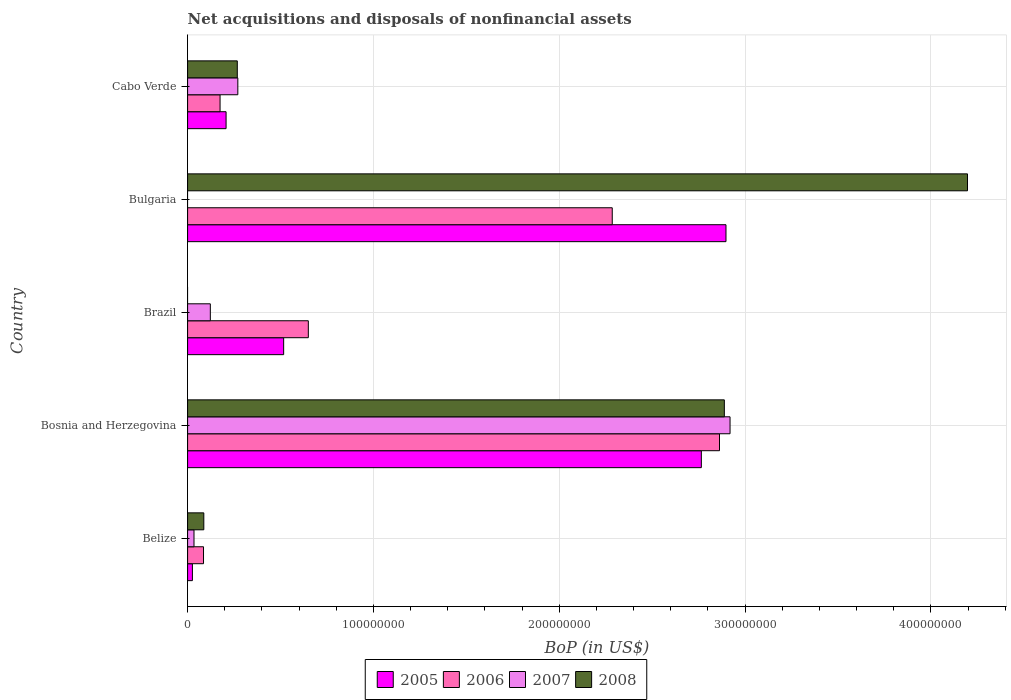How many groups of bars are there?
Offer a very short reply. 5. What is the label of the 4th group of bars from the top?
Offer a very short reply. Bosnia and Herzegovina. In how many cases, is the number of bars for a given country not equal to the number of legend labels?
Make the answer very short. 2. What is the Balance of Payments in 2007 in Bosnia and Herzegovina?
Provide a short and direct response. 2.92e+08. Across all countries, what is the maximum Balance of Payments in 2008?
Offer a very short reply. 4.20e+08. In which country was the Balance of Payments in 2005 maximum?
Ensure brevity in your answer.  Bulgaria. What is the total Balance of Payments in 2007 in the graph?
Keep it short and to the point. 3.35e+08. What is the difference between the Balance of Payments in 2007 in Bosnia and Herzegovina and that in Brazil?
Make the answer very short. 2.80e+08. What is the difference between the Balance of Payments in 2008 in Brazil and the Balance of Payments in 2006 in Bosnia and Herzegovina?
Ensure brevity in your answer.  -2.86e+08. What is the average Balance of Payments in 2005 per country?
Offer a terse response. 1.28e+08. What is the difference between the Balance of Payments in 2005 and Balance of Payments in 2007 in Belize?
Provide a succinct answer. -8.56e+05. What is the ratio of the Balance of Payments in 2008 in Bosnia and Herzegovina to that in Bulgaria?
Your response must be concise. 0.69. Is the Balance of Payments in 2006 in Bosnia and Herzegovina less than that in Brazil?
Give a very brief answer. No. What is the difference between the highest and the second highest Balance of Payments in 2006?
Offer a terse response. 5.77e+07. What is the difference between the highest and the lowest Balance of Payments in 2007?
Offer a very short reply. 2.92e+08. In how many countries, is the Balance of Payments in 2006 greater than the average Balance of Payments in 2006 taken over all countries?
Your answer should be compact. 2. Is the sum of the Balance of Payments in 2008 in Bosnia and Herzegovina and Cabo Verde greater than the maximum Balance of Payments in 2006 across all countries?
Provide a succinct answer. Yes. Is it the case that in every country, the sum of the Balance of Payments in 2006 and Balance of Payments in 2008 is greater than the sum of Balance of Payments in 2005 and Balance of Payments in 2007?
Your answer should be compact. Yes. Is it the case that in every country, the sum of the Balance of Payments in 2007 and Balance of Payments in 2006 is greater than the Balance of Payments in 2005?
Keep it short and to the point. No. How many bars are there?
Your response must be concise. 18. Are the values on the major ticks of X-axis written in scientific E-notation?
Offer a very short reply. No. Does the graph contain any zero values?
Give a very brief answer. Yes. Does the graph contain grids?
Make the answer very short. Yes. Where does the legend appear in the graph?
Offer a very short reply. Bottom center. How are the legend labels stacked?
Keep it short and to the point. Horizontal. What is the title of the graph?
Your answer should be compact. Net acquisitions and disposals of nonfinancial assets. Does "1970" appear as one of the legend labels in the graph?
Your answer should be very brief. No. What is the label or title of the X-axis?
Your answer should be compact. BoP (in US$). What is the BoP (in US$) in 2005 in Belize?
Offer a very short reply. 2.59e+06. What is the BoP (in US$) in 2006 in Belize?
Provide a succinct answer. 8.57e+06. What is the BoP (in US$) of 2007 in Belize?
Offer a terse response. 3.45e+06. What is the BoP (in US$) of 2008 in Belize?
Ensure brevity in your answer.  8.73e+06. What is the BoP (in US$) of 2005 in Bosnia and Herzegovina?
Your response must be concise. 2.76e+08. What is the BoP (in US$) in 2006 in Bosnia and Herzegovina?
Keep it short and to the point. 2.86e+08. What is the BoP (in US$) in 2007 in Bosnia and Herzegovina?
Your answer should be compact. 2.92e+08. What is the BoP (in US$) of 2008 in Bosnia and Herzegovina?
Give a very brief answer. 2.89e+08. What is the BoP (in US$) in 2005 in Brazil?
Provide a short and direct response. 5.17e+07. What is the BoP (in US$) of 2006 in Brazil?
Your answer should be very brief. 6.50e+07. What is the BoP (in US$) of 2007 in Brazil?
Make the answer very short. 1.22e+07. What is the BoP (in US$) of 2005 in Bulgaria?
Your response must be concise. 2.90e+08. What is the BoP (in US$) in 2006 in Bulgaria?
Keep it short and to the point. 2.28e+08. What is the BoP (in US$) of 2007 in Bulgaria?
Make the answer very short. 0. What is the BoP (in US$) of 2008 in Bulgaria?
Your answer should be very brief. 4.20e+08. What is the BoP (in US$) of 2005 in Cabo Verde?
Your response must be concise. 2.07e+07. What is the BoP (in US$) in 2006 in Cabo Verde?
Provide a succinct answer. 1.75e+07. What is the BoP (in US$) of 2007 in Cabo Verde?
Provide a short and direct response. 2.70e+07. What is the BoP (in US$) in 2008 in Cabo Verde?
Your answer should be compact. 2.67e+07. Across all countries, what is the maximum BoP (in US$) in 2005?
Provide a short and direct response. 2.90e+08. Across all countries, what is the maximum BoP (in US$) in 2006?
Offer a terse response. 2.86e+08. Across all countries, what is the maximum BoP (in US$) of 2007?
Provide a short and direct response. 2.92e+08. Across all countries, what is the maximum BoP (in US$) of 2008?
Give a very brief answer. 4.20e+08. Across all countries, what is the minimum BoP (in US$) of 2005?
Offer a terse response. 2.59e+06. Across all countries, what is the minimum BoP (in US$) in 2006?
Your response must be concise. 8.57e+06. Across all countries, what is the minimum BoP (in US$) of 2007?
Keep it short and to the point. 0. Across all countries, what is the minimum BoP (in US$) in 2008?
Provide a succinct answer. 0. What is the total BoP (in US$) of 2005 in the graph?
Your answer should be very brief. 6.41e+08. What is the total BoP (in US$) in 2006 in the graph?
Provide a succinct answer. 6.06e+08. What is the total BoP (in US$) in 2007 in the graph?
Offer a terse response. 3.35e+08. What is the total BoP (in US$) of 2008 in the graph?
Provide a succinct answer. 7.44e+08. What is the difference between the BoP (in US$) in 2005 in Belize and that in Bosnia and Herzegovina?
Offer a very short reply. -2.74e+08. What is the difference between the BoP (in US$) in 2006 in Belize and that in Bosnia and Herzegovina?
Make the answer very short. -2.78e+08. What is the difference between the BoP (in US$) in 2007 in Belize and that in Bosnia and Herzegovina?
Your answer should be compact. -2.88e+08. What is the difference between the BoP (in US$) in 2008 in Belize and that in Bosnia and Herzegovina?
Your answer should be very brief. -2.80e+08. What is the difference between the BoP (in US$) of 2005 in Belize and that in Brazil?
Your response must be concise. -4.91e+07. What is the difference between the BoP (in US$) of 2006 in Belize and that in Brazil?
Provide a succinct answer. -5.64e+07. What is the difference between the BoP (in US$) of 2007 in Belize and that in Brazil?
Offer a very short reply. -8.78e+06. What is the difference between the BoP (in US$) in 2005 in Belize and that in Bulgaria?
Make the answer very short. -2.87e+08. What is the difference between the BoP (in US$) in 2006 in Belize and that in Bulgaria?
Ensure brevity in your answer.  -2.20e+08. What is the difference between the BoP (in US$) in 2008 in Belize and that in Bulgaria?
Keep it short and to the point. -4.11e+08. What is the difference between the BoP (in US$) of 2005 in Belize and that in Cabo Verde?
Your answer should be compact. -1.81e+07. What is the difference between the BoP (in US$) in 2006 in Belize and that in Cabo Verde?
Give a very brief answer. -8.91e+06. What is the difference between the BoP (in US$) in 2007 in Belize and that in Cabo Verde?
Provide a short and direct response. -2.36e+07. What is the difference between the BoP (in US$) of 2008 in Belize and that in Cabo Verde?
Provide a short and direct response. -1.80e+07. What is the difference between the BoP (in US$) of 2005 in Bosnia and Herzegovina and that in Brazil?
Give a very brief answer. 2.25e+08. What is the difference between the BoP (in US$) in 2006 in Bosnia and Herzegovina and that in Brazil?
Provide a succinct answer. 2.21e+08. What is the difference between the BoP (in US$) of 2007 in Bosnia and Herzegovina and that in Brazil?
Provide a succinct answer. 2.80e+08. What is the difference between the BoP (in US$) in 2005 in Bosnia and Herzegovina and that in Bulgaria?
Your response must be concise. -1.33e+07. What is the difference between the BoP (in US$) in 2006 in Bosnia and Herzegovina and that in Bulgaria?
Give a very brief answer. 5.77e+07. What is the difference between the BoP (in US$) of 2008 in Bosnia and Herzegovina and that in Bulgaria?
Ensure brevity in your answer.  -1.31e+08. What is the difference between the BoP (in US$) of 2005 in Bosnia and Herzegovina and that in Cabo Verde?
Keep it short and to the point. 2.56e+08. What is the difference between the BoP (in US$) of 2006 in Bosnia and Herzegovina and that in Cabo Verde?
Keep it short and to the point. 2.69e+08. What is the difference between the BoP (in US$) of 2007 in Bosnia and Herzegovina and that in Cabo Verde?
Ensure brevity in your answer.  2.65e+08. What is the difference between the BoP (in US$) of 2008 in Bosnia and Herzegovina and that in Cabo Verde?
Your response must be concise. 2.62e+08. What is the difference between the BoP (in US$) in 2005 in Brazil and that in Bulgaria?
Ensure brevity in your answer.  -2.38e+08. What is the difference between the BoP (in US$) in 2006 in Brazil and that in Bulgaria?
Ensure brevity in your answer.  -1.64e+08. What is the difference between the BoP (in US$) of 2005 in Brazil and that in Cabo Verde?
Your answer should be very brief. 3.10e+07. What is the difference between the BoP (in US$) of 2006 in Brazil and that in Cabo Verde?
Make the answer very short. 4.75e+07. What is the difference between the BoP (in US$) in 2007 in Brazil and that in Cabo Verde?
Ensure brevity in your answer.  -1.48e+07. What is the difference between the BoP (in US$) in 2005 in Bulgaria and that in Cabo Verde?
Offer a very short reply. 2.69e+08. What is the difference between the BoP (in US$) in 2006 in Bulgaria and that in Cabo Verde?
Provide a succinct answer. 2.11e+08. What is the difference between the BoP (in US$) in 2008 in Bulgaria and that in Cabo Verde?
Keep it short and to the point. 3.93e+08. What is the difference between the BoP (in US$) in 2005 in Belize and the BoP (in US$) in 2006 in Bosnia and Herzegovina?
Your answer should be compact. -2.84e+08. What is the difference between the BoP (in US$) of 2005 in Belize and the BoP (in US$) of 2007 in Bosnia and Herzegovina?
Provide a short and direct response. -2.89e+08. What is the difference between the BoP (in US$) in 2005 in Belize and the BoP (in US$) in 2008 in Bosnia and Herzegovina?
Keep it short and to the point. -2.86e+08. What is the difference between the BoP (in US$) of 2006 in Belize and the BoP (in US$) of 2007 in Bosnia and Herzegovina?
Your answer should be compact. -2.83e+08. What is the difference between the BoP (in US$) in 2006 in Belize and the BoP (in US$) in 2008 in Bosnia and Herzegovina?
Make the answer very short. -2.80e+08. What is the difference between the BoP (in US$) of 2007 in Belize and the BoP (in US$) of 2008 in Bosnia and Herzegovina?
Offer a terse response. -2.85e+08. What is the difference between the BoP (in US$) of 2005 in Belize and the BoP (in US$) of 2006 in Brazil?
Ensure brevity in your answer.  -6.24e+07. What is the difference between the BoP (in US$) in 2005 in Belize and the BoP (in US$) in 2007 in Brazil?
Ensure brevity in your answer.  -9.64e+06. What is the difference between the BoP (in US$) in 2006 in Belize and the BoP (in US$) in 2007 in Brazil?
Your answer should be very brief. -3.66e+06. What is the difference between the BoP (in US$) of 2005 in Belize and the BoP (in US$) of 2006 in Bulgaria?
Your response must be concise. -2.26e+08. What is the difference between the BoP (in US$) in 2005 in Belize and the BoP (in US$) in 2008 in Bulgaria?
Make the answer very short. -4.17e+08. What is the difference between the BoP (in US$) in 2006 in Belize and the BoP (in US$) in 2008 in Bulgaria?
Your answer should be compact. -4.11e+08. What is the difference between the BoP (in US$) in 2007 in Belize and the BoP (in US$) in 2008 in Bulgaria?
Offer a very short reply. -4.16e+08. What is the difference between the BoP (in US$) in 2005 in Belize and the BoP (in US$) in 2006 in Cabo Verde?
Offer a terse response. -1.49e+07. What is the difference between the BoP (in US$) in 2005 in Belize and the BoP (in US$) in 2007 in Cabo Verde?
Keep it short and to the point. -2.44e+07. What is the difference between the BoP (in US$) in 2005 in Belize and the BoP (in US$) in 2008 in Cabo Verde?
Provide a succinct answer. -2.42e+07. What is the difference between the BoP (in US$) of 2006 in Belize and the BoP (in US$) of 2007 in Cabo Verde?
Ensure brevity in your answer.  -1.85e+07. What is the difference between the BoP (in US$) in 2006 in Belize and the BoP (in US$) in 2008 in Cabo Verde?
Your answer should be compact. -1.82e+07. What is the difference between the BoP (in US$) of 2007 in Belize and the BoP (in US$) of 2008 in Cabo Verde?
Offer a terse response. -2.33e+07. What is the difference between the BoP (in US$) in 2005 in Bosnia and Herzegovina and the BoP (in US$) in 2006 in Brazil?
Ensure brevity in your answer.  2.11e+08. What is the difference between the BoP (in US$) in 2005 in Bosnia and Herzegovina and the BoP (in US$) in 2007 in Brazil?
Provide a short and direct response. 2.64e+08. What is the difference between the BoP (in US$) in 2006 in Bosnia and Herzegovina and the BoP (in US$) in 2007 in Brazil?
Offer a terse response. 2.74e+08. What is the difference between the BoP (in US$) in 2005 in Bosnia and Herzegovina and the BoP (in US$) in 2006 in Bulgaria?
Ensure brevity in your answer.  4.79e+07. What is the difference between the BoP (in US$) of 2005 in Bosnia and Herzegovina and the BoP (in US$) of 2008 in Bulgaria?
Your answer should be compact. -1.43e+08. What is the difference between the BoP (in US$) in 2006 in Bosnia and Herzegovina and the BoP (in US$) in 2008 in Bulgaria?
Offer a very short reply. -1.33e+08. What is the difference between the BoP (in US$) in 2007 in Bosnia and Herzegovina and the BoP (in US$) in 2008 in Bulgaria?
Offer a very short reply. -1.28e+08. What is the difference between the BoP (in US$) of 2005 in Bosnia and Herzegovina and the BoP (in US$) of 2006 in Cabo Verde?
Your response must be concise. 2.59e+08. What is the difference between the BoP (in US$) of 2005 in Bosnia and Herzegovina and the BoP (in US$) of 2007 in Cabo Verde?
Give a very brief answer. 2.49e+08. What is the difference between the BoP (in US$) in 2005 in Bosnia and Herzegovina and the BoP (in US$) in 2008 in Cabo Verde?
Provide a short and direct response. 2.50e+08. What is the difference between the BoP (in US$) in 2006 in Bosnia and Herzegovina and the BoP (in US$) in 2007 in Cabo Verde?
Provide a short and direct response. 2.59e+08. What is the difference between the BoP (in US$) of 2006 in Bosnia and Herzegovina and the BoP (in US$) of 2008 in Cabo Verde?
Provide a short and direct response. 2.59e+08. What is the difference between the BoP (in US$) of 2007 in Bosnia and Herzegovina and the BoP (in US$) of 2008 in Cabo Verde?
Provide a short and direct response. 2.65e+08. What is the difference between the BoP (in US$) in 2005 in Brazil and the BoP (in US$) in 2006 in Bulgaria?
Provide a succinct answer. -1.77e+08. What is the difference between the BoP (in US$) in 2005 in Brazil and the BoP (in US$) in 2008 in Bulgaria?
Provide a short and direct response. -3.68e+08. What is the difference between the BoP (in US$) of 2006 in Brazil and the BoP (in US$) of 2008 in Bulgaria?
Offer a terse response. -3.55e+08. What is the difference between the BoP (in US$) in 2007 in Brazil and the BoP (in US$) in 2008 in Bulgaria?
Make the answer very short. -4.07e+08. What is the difference between the BoP (in US$) of 2005 in Brazil and the BoP (in US$) of 2006 in Cabo Verde?
Ensure brevity in your answer.  3.42e+07. What is the difference between the BoP (in US$) in 2005 in Brazil and the BoP (in US$) in 2007 in Cabo Verde?
Offer a very short reply. 2.47e+07. What is the difference between the BoP (in US$) of 2005 in Brazil and the BoP (in US$) of 2008 in Cabo Verde?
Your answer should be very brief. 2.49e+07. What is the difference between the BoP (in US$) of 2006 in Brazil and the BoP (in US$) of 2007 in Cabo Verde?
Keep it short and to the point. 3.79e+07. What is the difference between the BoP (in US$) in 2006 in Brazil and the BoP (in US$) in 2008 in Cabo Verde?
Provide a short and direct response. 3.82e+07. What is the difference between the BoP (in US$) of 2007 in Brazil and the BoP (in US$) of 2008 in Cabo Verde?
Your answer should be compact. -1.45e+07. What is the difference between the BoP (in US$) of 2005 in Bulgaria and the BoP (in US$) of 2006 in Cabo Verde?
Give a very brief answer. 2.72e+08. What is the difference between the BoP (in US$) of 2005 in Bulgaria and the BoP (in US$) of 2007 in Cabo Verde?
Your answer should be compact. 2.63e+08. What is the difference between the BoP (in US$) in 2005 in Bulgaria and the BoP (in US$) in 2008 in Cabo Verde?
Offer a very short reply. 2.63e+08. What is the difference between the BoP (in US$) in 2006 in Bulgaria and the BoP (in US$) in 2007 in Cabo Verde?
Make the answer very short. 2.01e+08. What is the difference between the BoP (in US$) of 2006 in Bulgaria and the BoP (in US$) of 2008 in Cabo Verde?
Your answer should be compact. 2.02e+08. What is the average BoP (in US$) of 2005 per country?
Make the answer very short. 1.28e+08. What is the average BoP (in US$) of 2006 per country?
Your response must be concise. 1.21e+08. What is the average BoP (in US$) in 2007 per country?
Your response must be concise. 6.69e+07. What is the average BoP (in US$) in 2008 per country?
Offer a terse response. 1.49e+08. What is the difference between the BoP (in US$) in 2005 and BoP (in US$) in 2006 in Belize?
Give a very brief answer. -5.98e+06. What is the difference between the BoP (in US$) of 2005 and BoP (in US$) of 2007 in Belize?
Your response must be concise. -8.56e+05. What is the difference between the BoP (in US$) of 2005 and BoP (in US$) of 2008 in Belize?
Provide a succinct answer. -6.14e+06. What is the difference between the BoP (in US$) in 2006 and BoP (in US$) in 2007 in Belize?
Make the answer very short. 5.12e+06. What is the difference between the BoP (in US$) of 2006 and BoP (in US$) of 2008 in Belize?
Keep it short and to the point. -1.61e+05. What is the difference between the BoP (in US$) of 2007 and BoP (in US$) of 2008 in Belize?
Your answer should be compact. -5.28e+06. What is the difference between the BoP (in US$) in 2005 and BoP (in US$) in 2006 in Bosnia and Herzegovina?
Give a very brief answer. -9.77e+06. What is the difference between the BoP (in US$) in 2005 and BoP (in US$) in 2007 in Bosnia and Herzegovina?
Give a very brief answer. -1.54e+07. What is the difference between the BoP (in US$) in 2005 and BoP (in US$) in 2008 in Bosnia and Herzegovina?
Offer a terse response. -1.24e+07. What is the difference between the BoP (in US$) in 2006 and BoP (in US$) in 2007 in Bosnia and Herzegovina?
Offer a very short reply. -5.67e+06. What is the difference between the BoP (in US$) in 2006 and BoP (in US$) in 2008 in Bosnia and Herzegovina?
Provide a succinct answer. -2.60e+06. What is the difference between the BoP (in US$) of 2007 and BoP (in US$) of 2008 in Bosnia and Herzegovina?
Provide a short and direct response. 3.07e+06. What is the difference between the BoP (in US$) of 2005 and BoP (in US$) of 2006 in Brazil?
Ensure brevity in your answer.  -1.33e+07. What is the difference between the BoP (in US$) in 2005 and BoP (in US$) in 2007 in Brazil?
Provide a short and direct response. 3.95e+07. What is the difference between the BoP (in US$) of 2006 and BoP (in US$) of 2007 in Brazil?
Keep it short and to the point. 5.27e+07. What is the difference between the BoP (in US$) of 2005 and BoP (in US$) of 2006 in Bulgaria?
Offer a very short reply. 6.12e+07. What is the difference between the BoP (in US$) in 2005 and BoP (in US$) in 2008 in Bulgaria?
Your response must be concise. -1.30e+08. What is the difference between the BoP (in US$) in 2006 and BoP (in US$) in 2008 in Bulgaria?
Keep it short and to the point. -1.91e+08. What is the difference between the BoP (in US$) of 2005 and BoP (in US$) of 2006 in Cabo Verde?
Provide a short and direct response. 3.24e+06. What is the difference between the BoP (in US$) in 2005 and BoP (in US$) in 2007 in Cabo Verde?
Make the answer very short. -6.32e+06. What is the difference between the BoP (in US$) in 2005 and BoP (in US$) in 2008 in Cabo Verde?
Provide a succinct answer. -6.04e+06. What is the difference between the BoP (in US$) of 2006 and BoP (in US$) of 2007 in Cabo Verde?
Make the answer very short. -9.56e+06. What is the difference between the BoP (in US$) of 2006 and BoP (in US$) of 2008 in Cabo Verde?
Ensure brevity in your answer.  -9.28e+06. What is the difference between the BoP (in US$) in 2007 and BoP (in US$) in 2008 in Cabo Verde?
Offer a very short reply. 2.85e+05. What is the ratio of the BoP (in US$) in 2005 in Belize to that in Bosnia and Herzegovina?
Provide a short and direct response. 0.01. What is the ratio of the BoP (in US$) of 2006 in Belize to that in Bosnia and Herzegovina?
Provide a succinct answer. 0.03. What is the ratio of the BoP (in US$) in 2007 in Belize to that in Bosnia and Herzegovina?
Your answer should be compact. 0.01. What is the ratio of the BoP (in US$) of 2008 in Belize to that in Bosnia and Herzegovina?
Offer a very short reply. 0.03. What is the ratio of the BoP (in US$) of 2005 in Belize to that in Brazil?
Offer a very short reply. 0.05. What is the ratio of the BoP (in US$) in 2006 in Belize to that in Brazil?
Your response must be concise. 0.13. What is the ratio of the BoP (in US$) in 2007 in Belize to that in Brazil?
Make the answer very short. 0.28. What is the ratio of the BoP (in US$) of 2005 in Belize to that in Bulgaria?
Offer a very short reply. 0.01. What is the ratio of the BoP (in US$) of 2006 in Belize to that in Bulgaria?
Provide a short and direct response. 0.04. What is the ratio of the BoP (in US$) in 2008 in Belize to that in Bulgaria?
Your response must be concise. 0.02. What is the ratio of the BoP (in US$) of 2005 in Belize to that in Cabo Verde?
Provide a succinct answer. 0.13. What is the ratio of the BoP (in US$) of 2006 in Belize to that in Cabo Verde?
Your answer should be very brief. 0.49. What is the ratio of the BoP (in US$) of 2007 in Belize to that in Cabo Verde?
Make the answer very short. 0.13. What is the ratio of the BoP (in US$) in 2008 in Belize to that in Cabo Verde?
Your answer should be compact. 0.33. What is the ratio of the BoP (in US$) in 2005 in Bosnia and Herzegovina to that in Brazil?
Ensure brevity in your answer.  5.35. What is the ratio of the BoP (in US$) in 2006 in Bosnia and Herzegovina to that in Brazil?
Provide a succinct answer. 4.41. What is the ratio of the BoP (in US$) in 2007 in Bosnia and Herzegovina to that in Brazil?
Make the answer very short. 23.87. What is the ratio of the BoP (in US$) of 2005 in Bosnia and Herzegovina to that in Bulgaria?
Your response must be concise. 0.95. What is the ratio of the BoP (in US$) of 2006 in Bosnia and Herzegovina to that in Bulgaria?
Offer a very short reply. 1.25. What is the ratio of the BoP (in US$) of 2008 in Bosnia and Herzegovina to that in Bulgaria?
Make the answer very short. 0.69. What is the ratio of the BoP (in US$) in 2005 in Bosnia and Herzegovina to that in Cabo Verde?
Keep it short and to the point. 13.35. What is the ratio of the BoP (in US$) of 2006 in Bosnia and Herzegovina to that in Cabo Verde?
Offer a very short reply. 16.38. What is the ratio of the BoP (in US$) of 2007 in Bosnia and Herzegovina to that in Cabo Verde?
Your response must be concise. 10.8. What is the ratio of the BoP (in US$) of 2008 in Bosnia and Herzegovina to that in Cabo Verde?
Offer a terse response. 10.8. What is the ratio of the BoP (in US$) of 2005 in Brazil to that in Bulgaria?
Your answer should be very brief. 0.18. What is the ratio of the BoP (in US$) in 2006 in Brazil to that in Bulgaria?
Offer a terse response. 0.28. What is the ratio of the BoP (in US$) of 2005 in Brazil to that in Cabo Verde?
Your response must be concise. 2.5. What is the ratio of the BoP (in US$) in 2006 in Brazil to that in Cabo Verde?
Your answer should be very brief. 3.72. What is the ratio of the BoP (in US$) of 2007 in Brazil to that in Cabo Verde?
Offer a very short reply. 0.45. What is the ratio of the BoP (in US$) in 2005 in Bulgaria to that in Cabo Verde?
Keep it short and to the point. 13.99. What is the ratio of the BoP (in US$) of 2006 in Bulgaria to that in Cabo Verde?
Make the answer very short. 13.08. What is the ratio of the BoP (in US$) of 2008 in Bulgaria to that in Cabo Verde?
Provide a short and direct response. 15.69. What is the difference between the highest and the second highest BoP (in US$) in 2005?
Give a very brief answer. 1.33e+07. What is the difference between the highest and the second highest BoP (in US$) of 2006?
Offer a terse response. 5.77e+07. What is the difference between the highest and the second highest BoP (in US$) in 2007?
Offer a very short reply. 2.65e+08. What is the difference between the highest and the second highest BoP (in US$) of 2008?
Your answer should be compact. 1.31e+08. What is the difference between the highest and the lowest BoP (in US$) of 2005?
Provide a succinct answer. 2.87e+08. What is the difference between the highest and the lowest BoP (in US$) in 2006?
Offer a terse response. 2.78e+08. What is the difference between the highest and the lowest BoP (in US$) of 2007?
Offer a very short reply. 2.92e+08. What is the difference between the highest and the lowest BoP (in US$) in 2008?
Keep it short and to the point. 4.20e+08. 